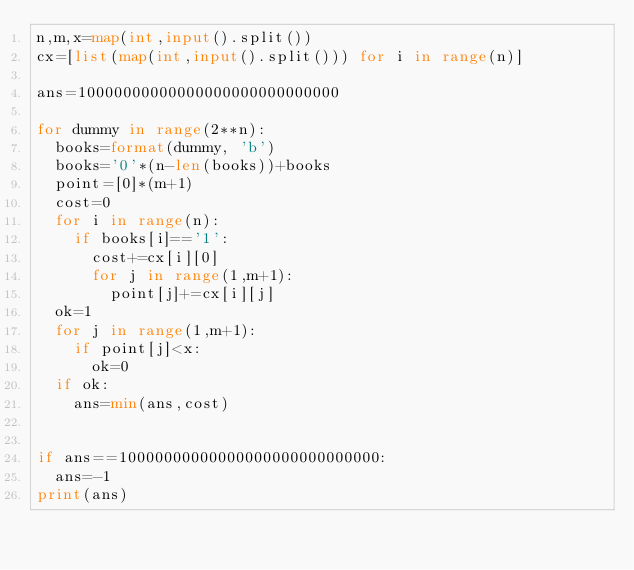<code> <loc_0><loc_0><loc_500><loc_500><_Python_>n,m,x=map(int,input().split())
cx=[list(map(int,input().split())) for i in range(n)]

ans=10000000000000000000000000000

for dummy in range(2**n):
  books=format(dummy, 'b')
  books='0'*(n-len(books))+books
  point=[0]*(m+1)
  cost=0
  for i in range(n):
    if books[i]=='1':
      cost+=cx[i][0]
      for j in range(1,m+1):
        point[j]+=cx[i][j]
  ok=1
  for j in range(1,m+1):
    if point[j]<x:
      ok=0
  if ok:
    ans=min(ans,cost)


if ans==10000000000000000000000000000:
  ans=-1
print(ans)</code> 